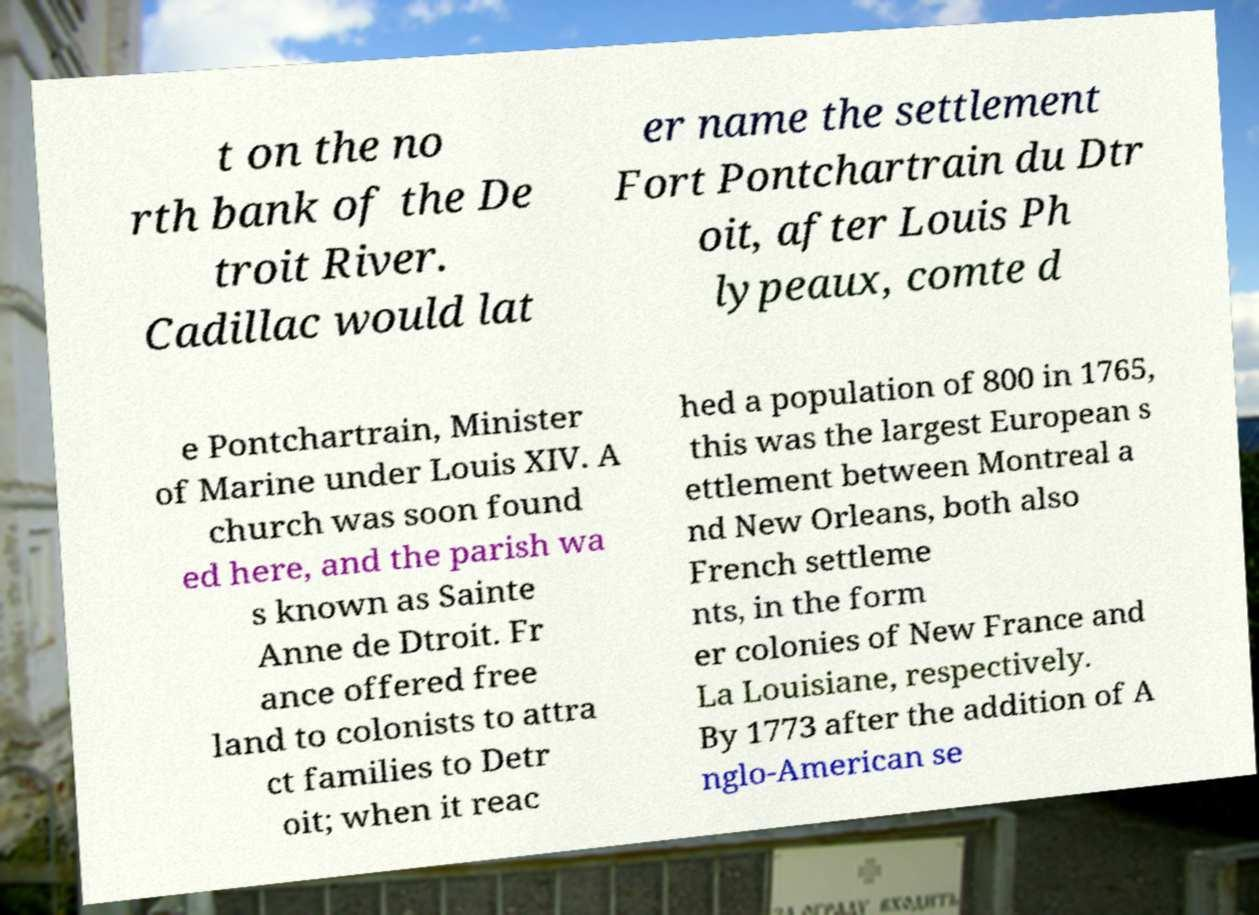I need the written content from this picture converted into text. Can you do that? t on the no rth bank of the De troit River. Cadillac would lat er name the settlement Fort Pontchartrain du Dtr oit, after Louis Ph lypeaux, comte d e Pontchartrain, Minister of Marine under Louis XIV. A church was soon found ed here, and the parish wa s known as Sainte Anne de Dtroit. Fr ance offered free land to colonists to attra ct families to Detr oit; when it reac hed a population of 800 in 1765, this was the largest European s ettlement between Montreal a nd New Orleans, both also French settleme nts, in the form er colonies of New France and La Louisiane, respectively. By 1773 after the addition of A nglo-American se 